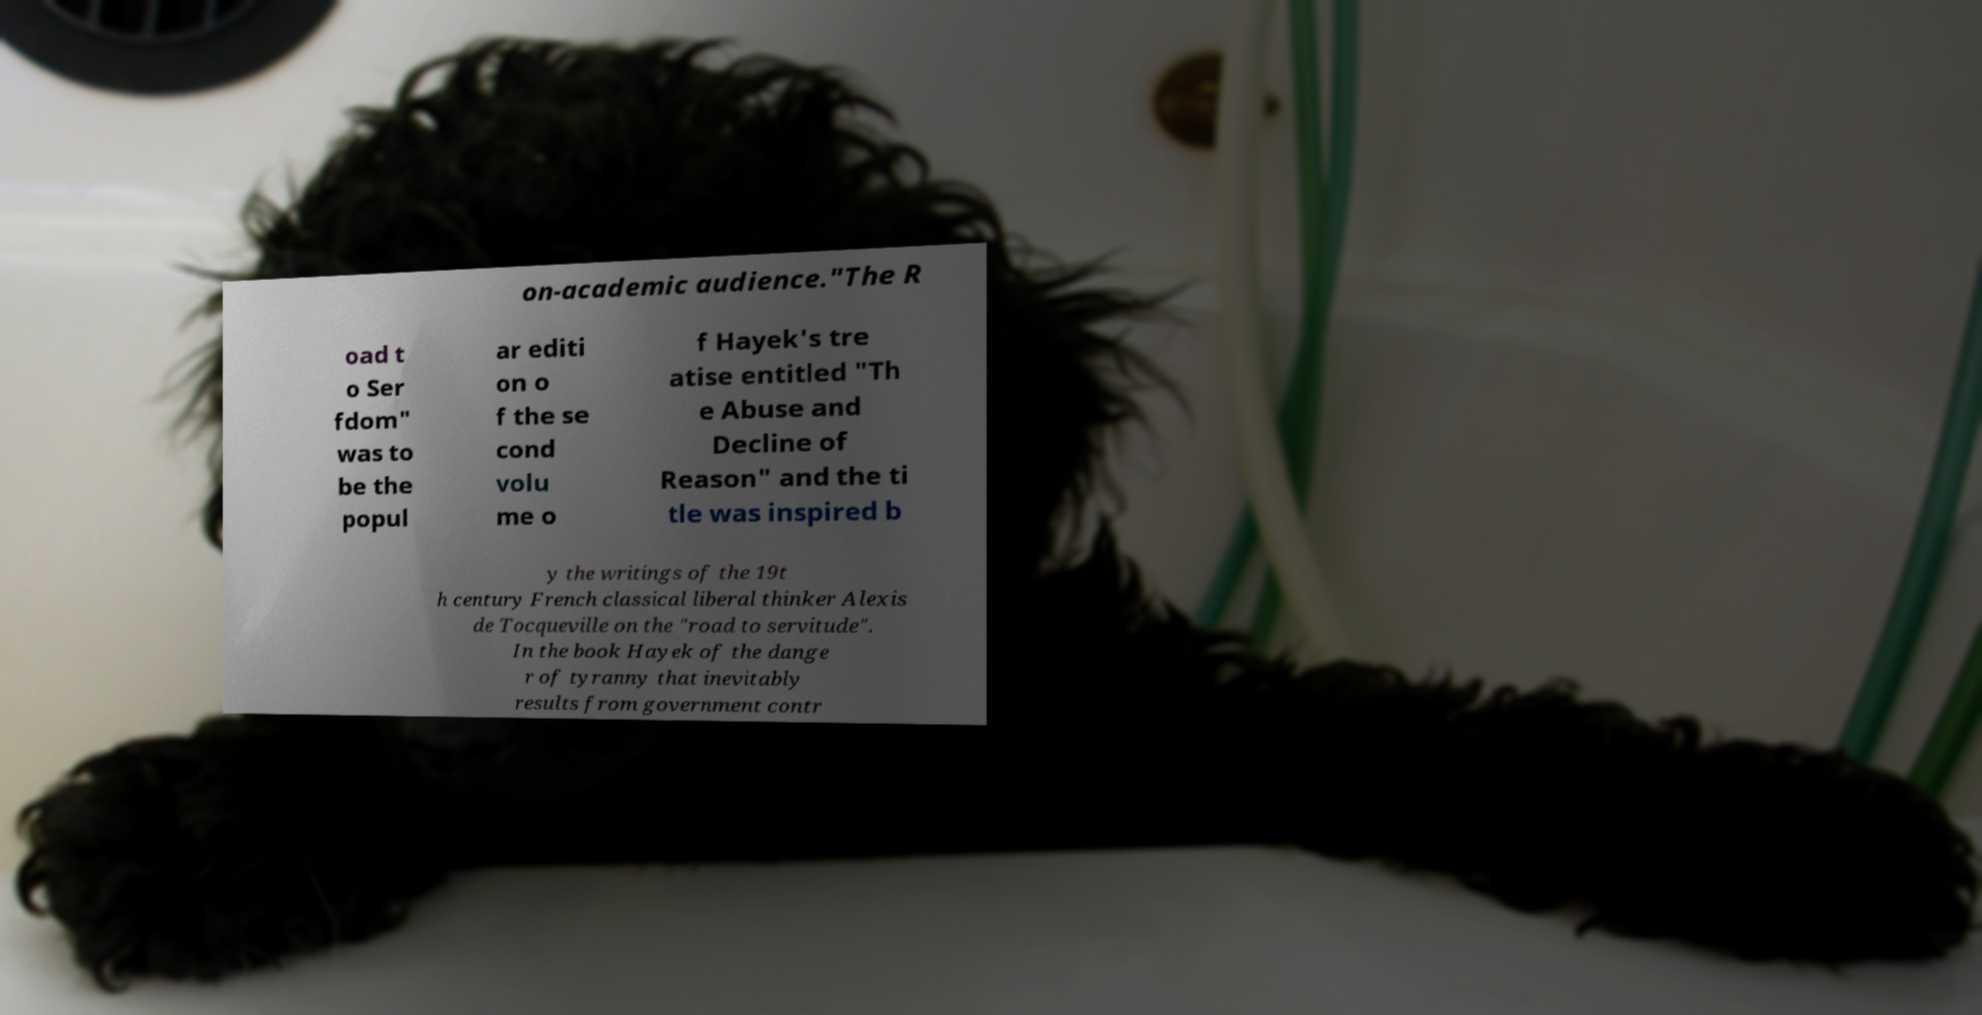There's text embedded in this image that I need extracted. Can you transcribe it verbatim? on-academic audience."The R oad t o Ser fdom" was to be the popul ar editi on o f the se cond volu me o f Hayek's tre atise entitled "Th e Abuse and Decline of Reason" and the ti tle was inspired b y the writings of the 19t h century French classical liberal thinker Alexis de Tocqueville on the "road to servitude". In the book Hayek of the dange r of tyranny that inevitably results from government contr 